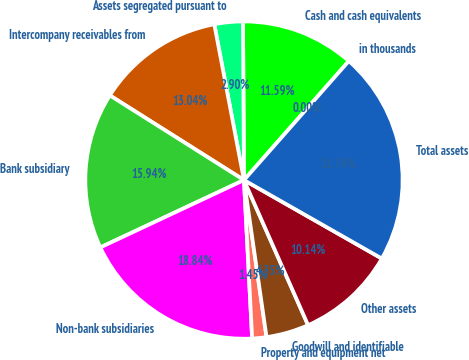<chart> <loc_0><loc_0><loc_500><loc_500><pie_chart><fcel>in thousands<fcel>Cash and cash equivalents<fcel>Assets segregated pursuant to<fcel>Intercompany receivables from<fcel>Bank subsidiary<fcel>Non-bank subsidiaries<fcel>Property and equipment net<fcel>Goodwill and identifiable<fcel>Other assets<fcel>Total assets<nl><fcel>0.0%<fcel>11.59%<fcel>2.9%<fcel>13.04%<fcel>15.94%<fcel>18.84%<fcel>1.45%<fcel>4.35%<fcel>10.14%<fcel>21.74%<nl></chart> 